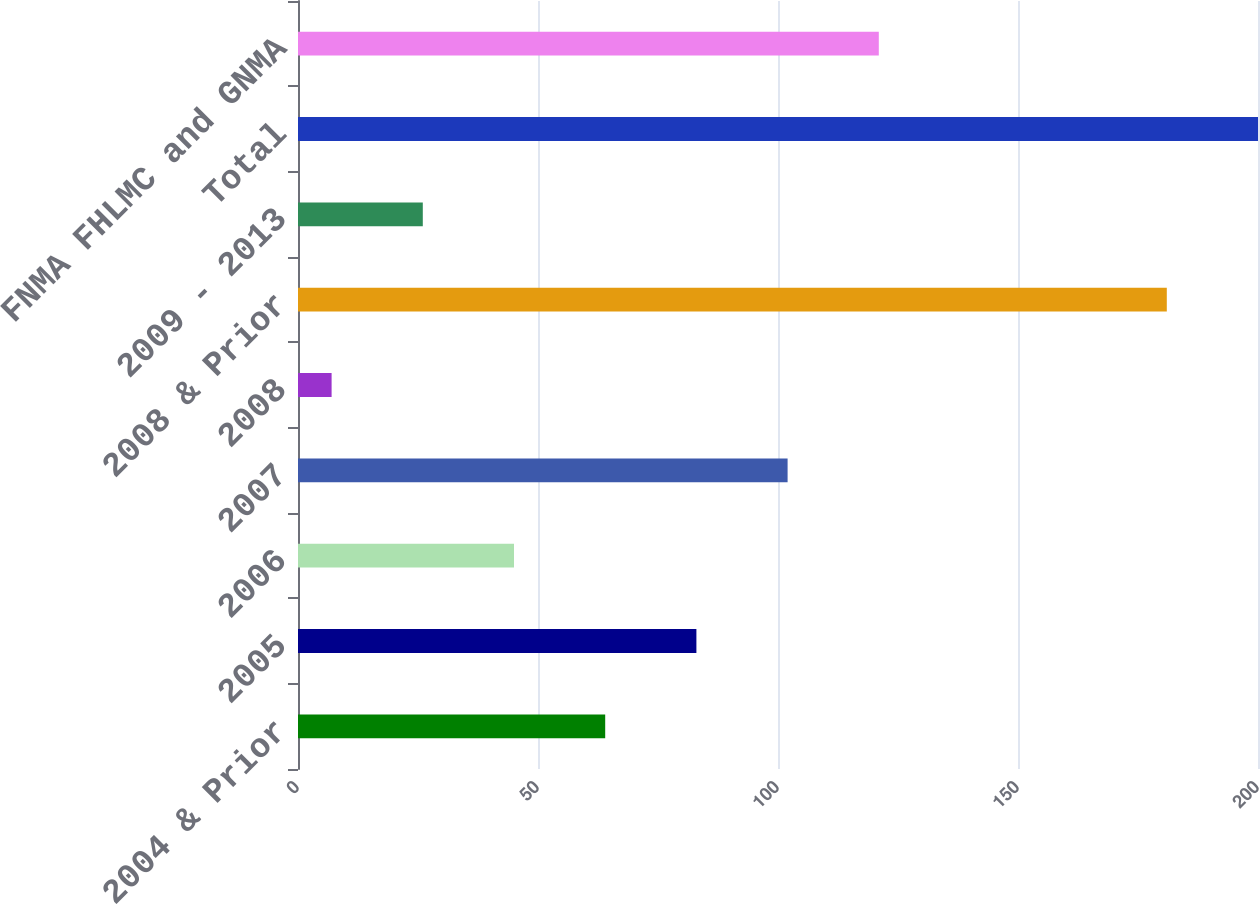Convert chart. <chart><loc_0><loc_0><loc_500><loc_500><bar_chart><fcel>2004 & Prior<fcel>2005<fcel>2006<fcel>2007<fcel>2008<fcel>2008 & Prior<fcel>2009 - 2013<fcel>Total<fcel>FNMA FHLMC and GNMA<nl><fcel>64<fcel>83<fcel>45<fcel>102<fcel>7<fcel>181<fcel>26<fcel>200<fcel>121<nl></chart> 